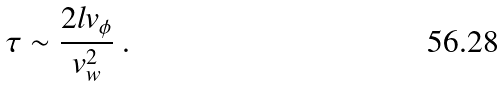<formula> <loc_0><loc_0><loc_500><loc_500>\tau \sim \frac { 2 l v _ { \phi } } { v _ { w } ^ { 2 } } \ .</formula> 